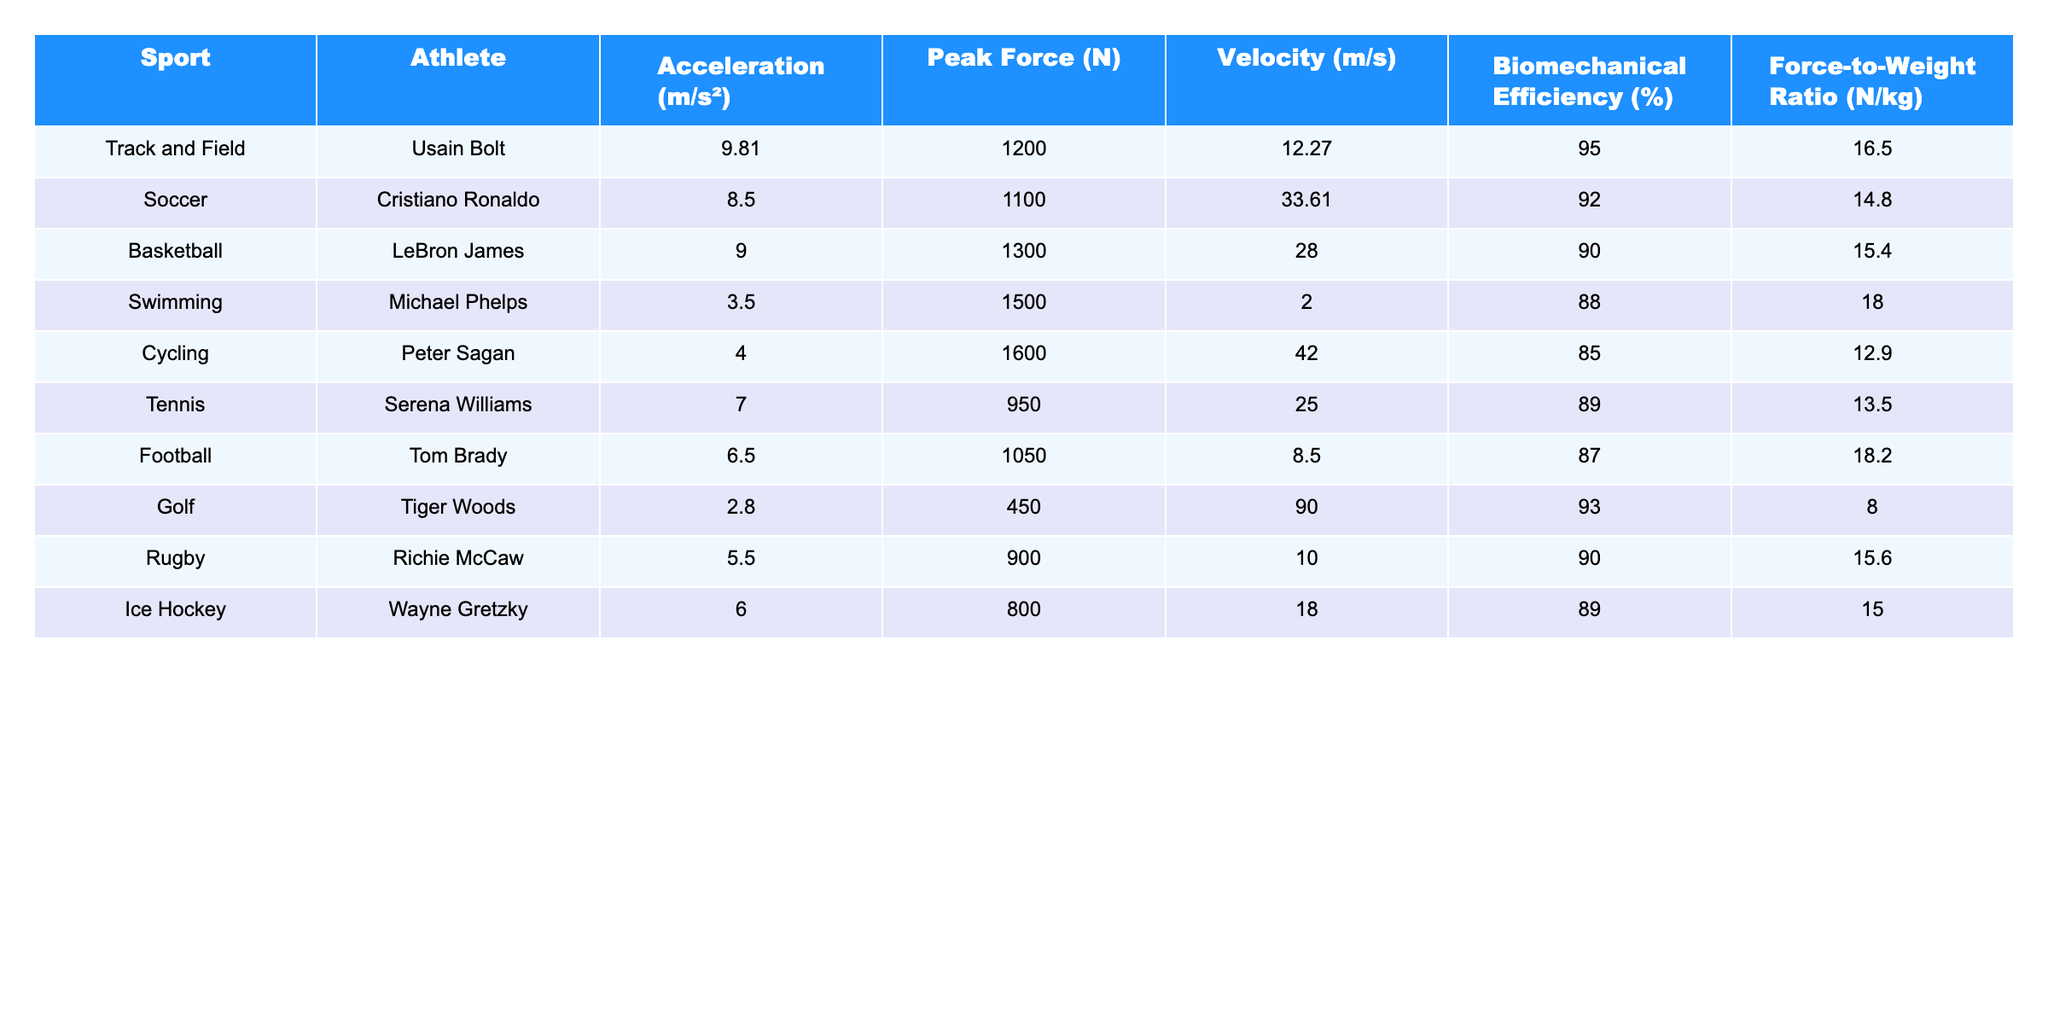What is Usain Bolt's acceleration in meters per second squared? According to the table, Usain Bolt's acceleration is listed under the "Acceleration (m/s²)" column. It shows a value of 9.81 m/s².
Answer: 9.81 m/s² Which athlete has the highest peak force in Newtons? The table lists the peak force values for each athlete. Michael Phelps has the highest peak force at 1500 N.
Answer: 1500 N What is the average velocity among the athletes in the table? To find the average velocity, we sum the velocities: 12.27 + 33.61 + 28.0 + 2.0 + 42.0 + 25.0 + 8.5 + 90.0 + 10.0 + 18.0 =  328.58 m/s. There are 10 athletes, so the average velocity is 328.58/10 = 32.858 m/s.
Answer: 32.86 m/s Is Serena Williams' force-to-weight ratio greater than 14? Serena Williams has a force-to-weight ratio of 13.5 N/kg, which is less than 14.
Answer: No Which sport has the highest biomechanical efficiency, and what is that value? Referring to the biomechanical efficiency column, Usain Bolt's values stand at the highest at 95%. Thus, Track and Field has the highest biomechanical efficiency.
Answer: Track and Field, 95% If we compare the acceleration of athletes, who has the greatest difference from the swimmer's acceleration? Michael Phelps' acceleration is 3.5 m/s². Usain Bolt has the highest acceleration of 9.81 m/s². The difference is calculated as 9.81 - 3.5 = 6.31 m/s².
Answer: 6.31 m/s² How many athletes have a force-to-weight ratio of greater than 15 N/kg? By analyzing the force-to-weight ratio column, Usain Bolt (16.5), LeBron James (15.4), and Tiger Woods (8.0) show only Usain Bolt has a force-to-weight ratio greater than 15 N/kg.
Answer: 1 Which athlete has the lowest velocity and what sport do they play? The velocity for each athlete is listed, and the lowest value belongs to Michael Phelps with 2.0 m/s, who competes in Swimming.
Answer: Michael Phelps, Swimming What is the difference in peak force between Cristiano Ronaldo and Tom Brady? Cristiano Ronaldo has a peak force of 1100 N, and Tom Brady has 1050 N. The difference is 1100 - 1050 = 50 N.
Answer: 50 N Are the athletes with the highest peak forces also those with the highest velocities? The highest peak force belongs to Michael Phelps at 1500 N while his velocity is the lowest (2.0 m/s). The highest velocity is 90.0 m/s from Tiger Woods (force 450 N). Hence, they are not the same.
Answer: No 